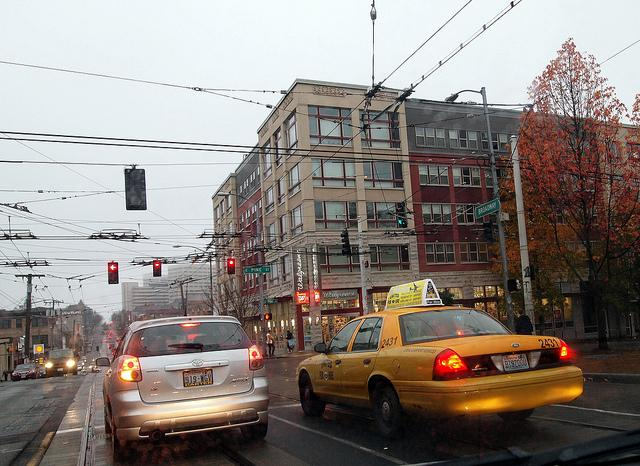Which car is stopped before white line? Please explain your reasoning. cab. The taxi is right before the white line in front of the stoplight. 